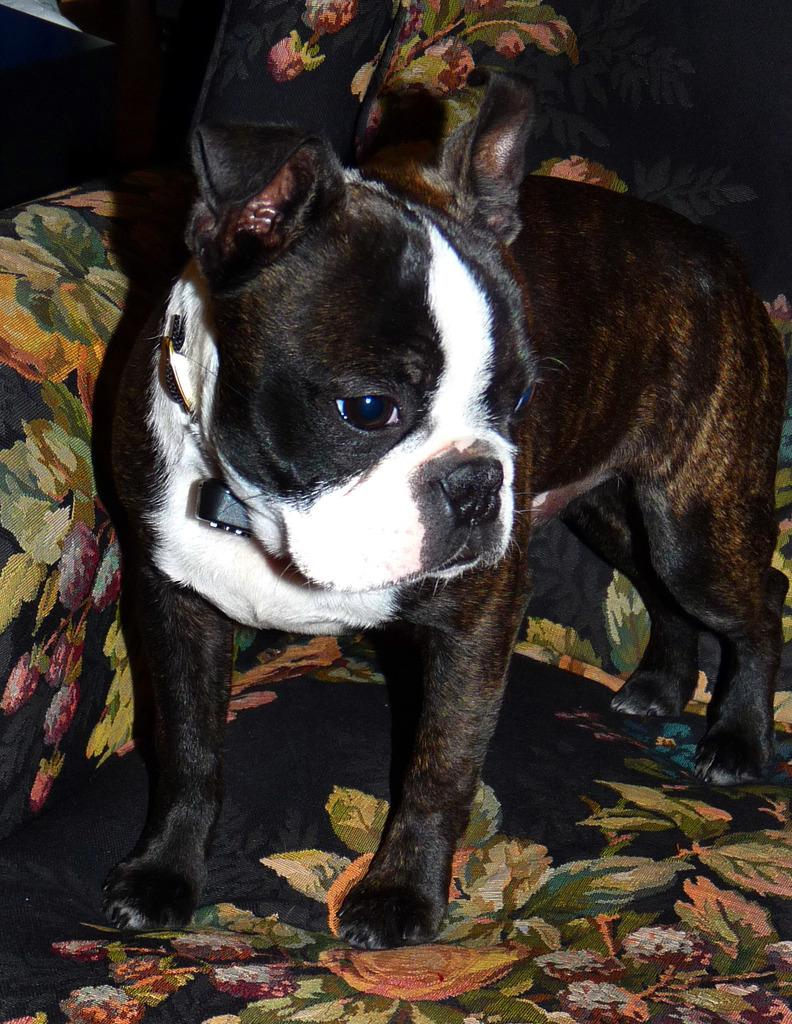What type of animal is in the image? There is a dog in the image. Where is the dog located in the image? The dog is standing on a colorful couch. Can you describe the dog's color pattern? The dog has a color pattern of white, black, and brown. What type of wound can be seen on the dog's back in the image? There is no wound visible on the dog's back in the image. Can you describe the bat that is flying around the dog in the image? There is no bat present in the image; it only features a dog standing on a couch. 